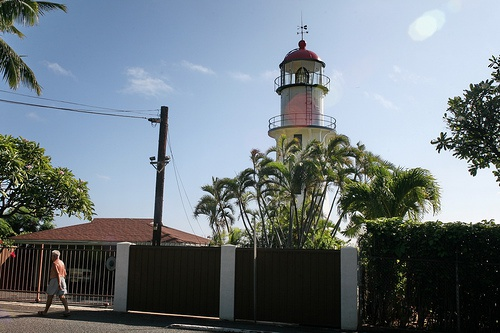Describe the objects in this image and their specific colors. I can see people in black, maroon, tan, and gray tones and car in black and gray tones in this image. 